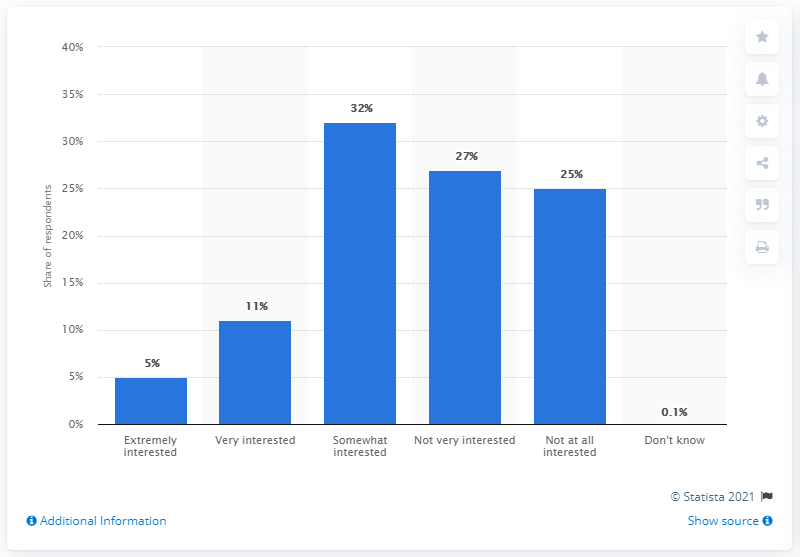Outline some significant characteristics in this image. 25% of the users were not at all interested in entertainment news. 